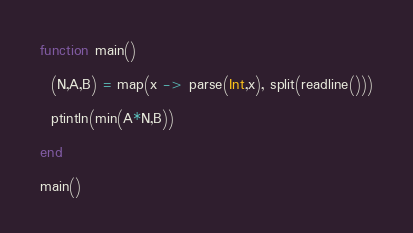Convert code to text. <code><loc_0><loc_0><loc_500><loc_500><_Julia_>function main()
  
  (N,A,B) = map(x -> parse(Int,x), split(readline()))
  
  ptintln(min(A*N,B))
  
end

main()</code> 